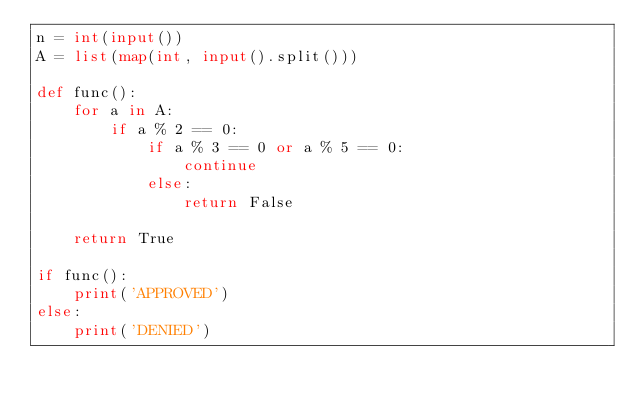Convert code to text. <code><loc_0><loc_0><loc_500><loc_500><_Python_>n = int(input())
A = list(map(int, input().split()))

def func():
    for a in A:
        if a % 2 == 0:
            if a % 3 == 0 or a % 5 == 0:
                continue
            else:
                return False
    
    return True

if func():
    print('APPROVED')
else:
    print('DENIED')
    </code> 